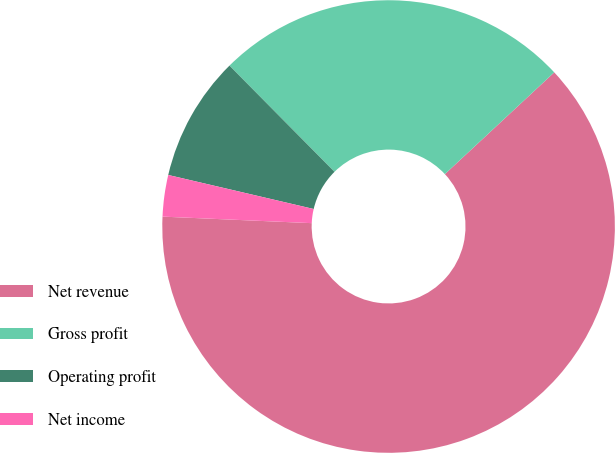Convert chart. <chart><loc_0><loc_0><loc_500><loc_500><pie_chart><fcel>Net revenue<fcel>Gross profit<fcel>Operating profit<fcel>Net income<nl><fcel>62.62%<fcel>25.48%<fcel>8.93%<fcel>2.96%<nl></chart> 